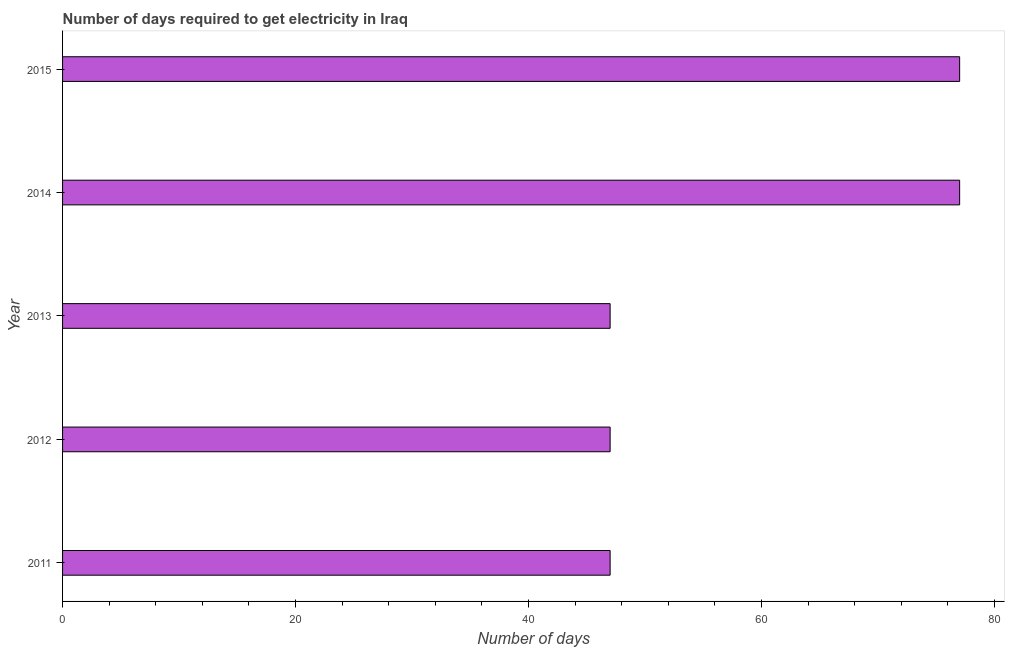Does the graph contain any zero values?
Give a very brief answer. No. Does the graph contain grids?
Make the answer very short. No. What is the title of the graph?
Provide a short and direct response. Number of days required to get electricity in Iraq. What is the label or title of the X-axis?
Your answer should be very brief. Number of days. What is the label or title of the Y-axis?
Make the answer very short. Year. Across all years, what is the maximum time to get electricity?
Keep it short and to the point. 77. Across all years, what is the minimum time to get electricity?
Make the answer very short. 47. In which year was the time to get electricity maximum?
Provide a short and direct response. 2014. What is the sum of the time to get electricity?
Provide a succinct answer. 295. What is the difference between the time to get electricity in 2012 and 2015?
Ensure brevity in your answer.  -30. What is the ratio of the time to get electricity in 2011 to that in 2015?
Give a very brief answer. 0.61. What is the difference between the highest and the second highest time to get electricity?
Ensure brevity in your answer.  0. Is the sum of the time to get electricity in 2011 and 2013 greater than the maximum time to get electricity across all years?
Provide a succinct answer. Yes. In how many years, is the time to get electricity greater than the average time to get electricity taken over all years?
Make the answer very short. 2. How many bars are there?
Provide a short and direct response. 5. Are the values on the major ticks of X-axis written in scientific E-notation?
Give a very brief answer. No. What is the Number of days in 2011?
Keep it short and to the point. 47. What is the Number of days of 2012?
Give a very brief answer. 47. What is the Number of days of 2013?
Your answer should be very brief. 47. What is the Number of days of 2014?
Your answer should be very brief. 77. What is the difference between the Number of days in 2011 and 2013?
Your answer should be compact. 0. What is the difference between the Number of days in 2011 and 2014?
Keep it short and to the point. -30. What is the difference between the Number of days in 2012 and 2013?
Offer a terse response. 0. What is the difference between the Number of days in 2012 and 2015?
Your answer should be compact. -30. What is the difference between the Number of days in 2013 and 2014?
Make the answer very short. -30. What is the difference between the Number of days in 2013 and 2015?
Your response must be concise. -30. What is the difference between the Number of days in 2014 and 2015?
Provide a short and direct response. 0. What is the ratio of the Number of days in 2011 to that in 2012?
Ensure brevity in your answer.  1. What is the ratio of the Number of days in 2011 to that in 2014?
Offer a terse response. 0.61. What is the ratio of the Number of days in 2011 to that in 2015?
Give a very brief answer. 0.61. What is the ratio of the Number of days in 2012 to that in 2013?
Your answer should be very brief. 1. What is the ratio of the Number of days in 2012 to that in 2014?
Make the answer very short. 0.61. What is the ratio of the Number of days in 2012 to that in 2015?
Offer a terse response. 0.61. What is the ratio of the Number of days in 2013 to that in 2014?
Your answer should be compact. 0.61. What is the ratio of the Number of days in 2013 to that in 2015?
Your response must be concise. 0.61. 